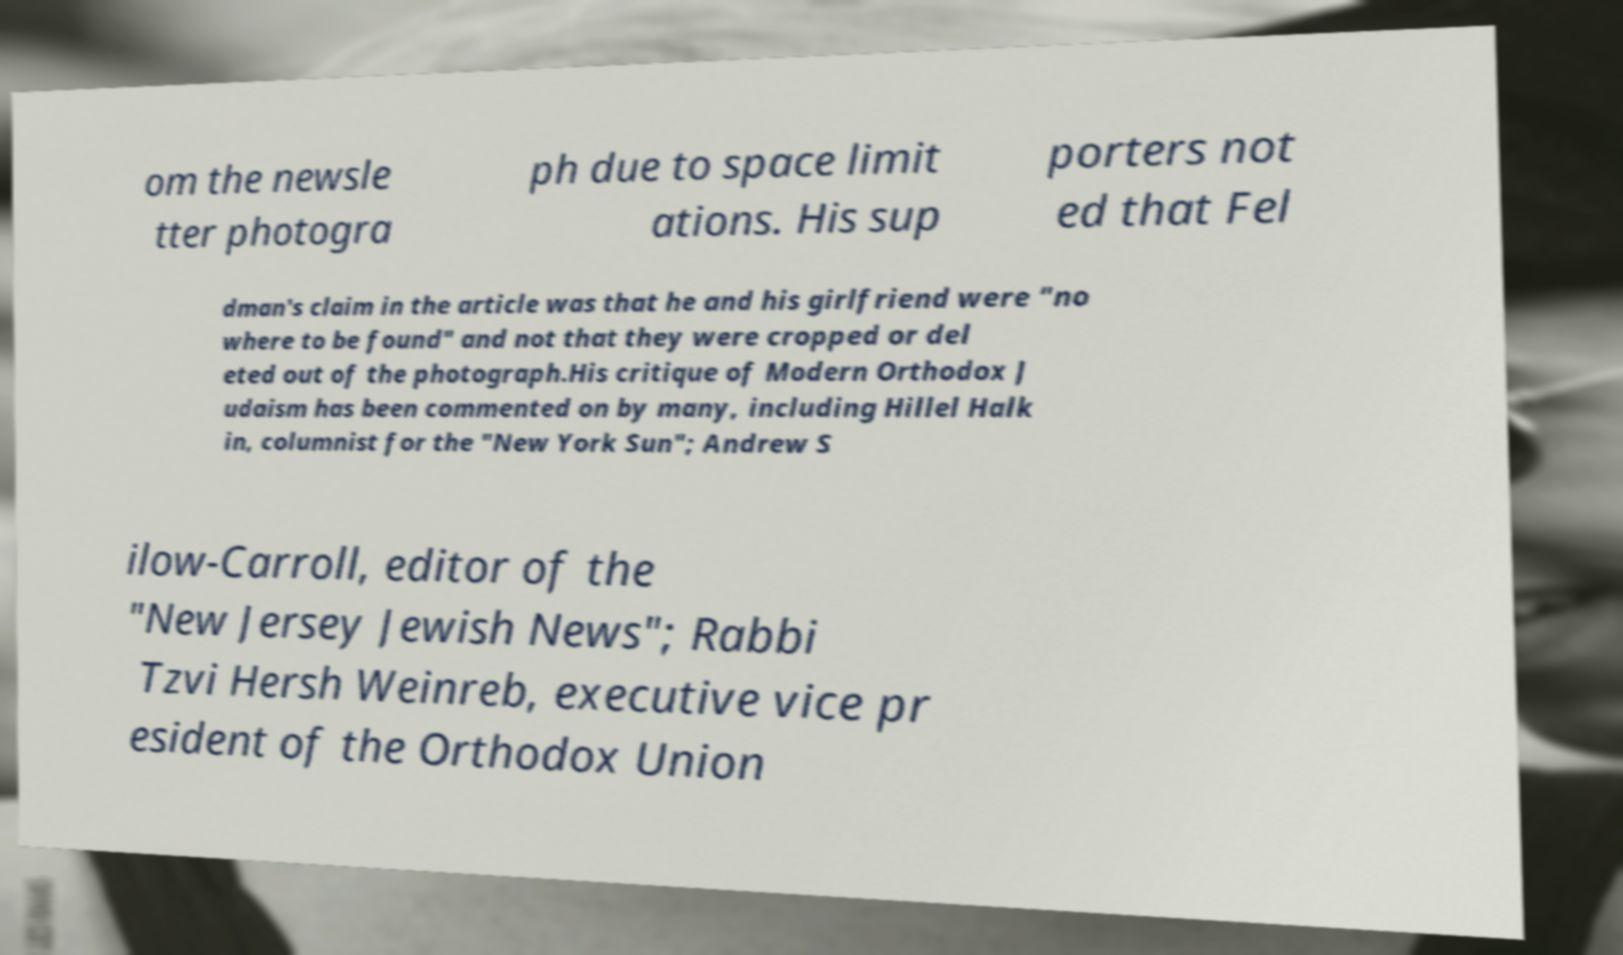Can you read and provide the text displayed in the image?This photo seems to have some interesting text. Can you extract and type it out for me? om the newsle tter photogra ph due to space limit ations. His sup porters not ed that Fel dman's claim in the article was that he and his girlfriend were "no where to be found" and not that they were cropped or del eted out of the photograph.His critique of Modern Orthodox J udaism has been commented on by many, including Hillel Halk in, columnist for the "New York Sun"; Andrew S ilow-Carroll, editor of the "New Jersey Jewish News"; Rabbi Tzvi Hersh Weinreb, executive vice pr esident of the Orthodox Union 